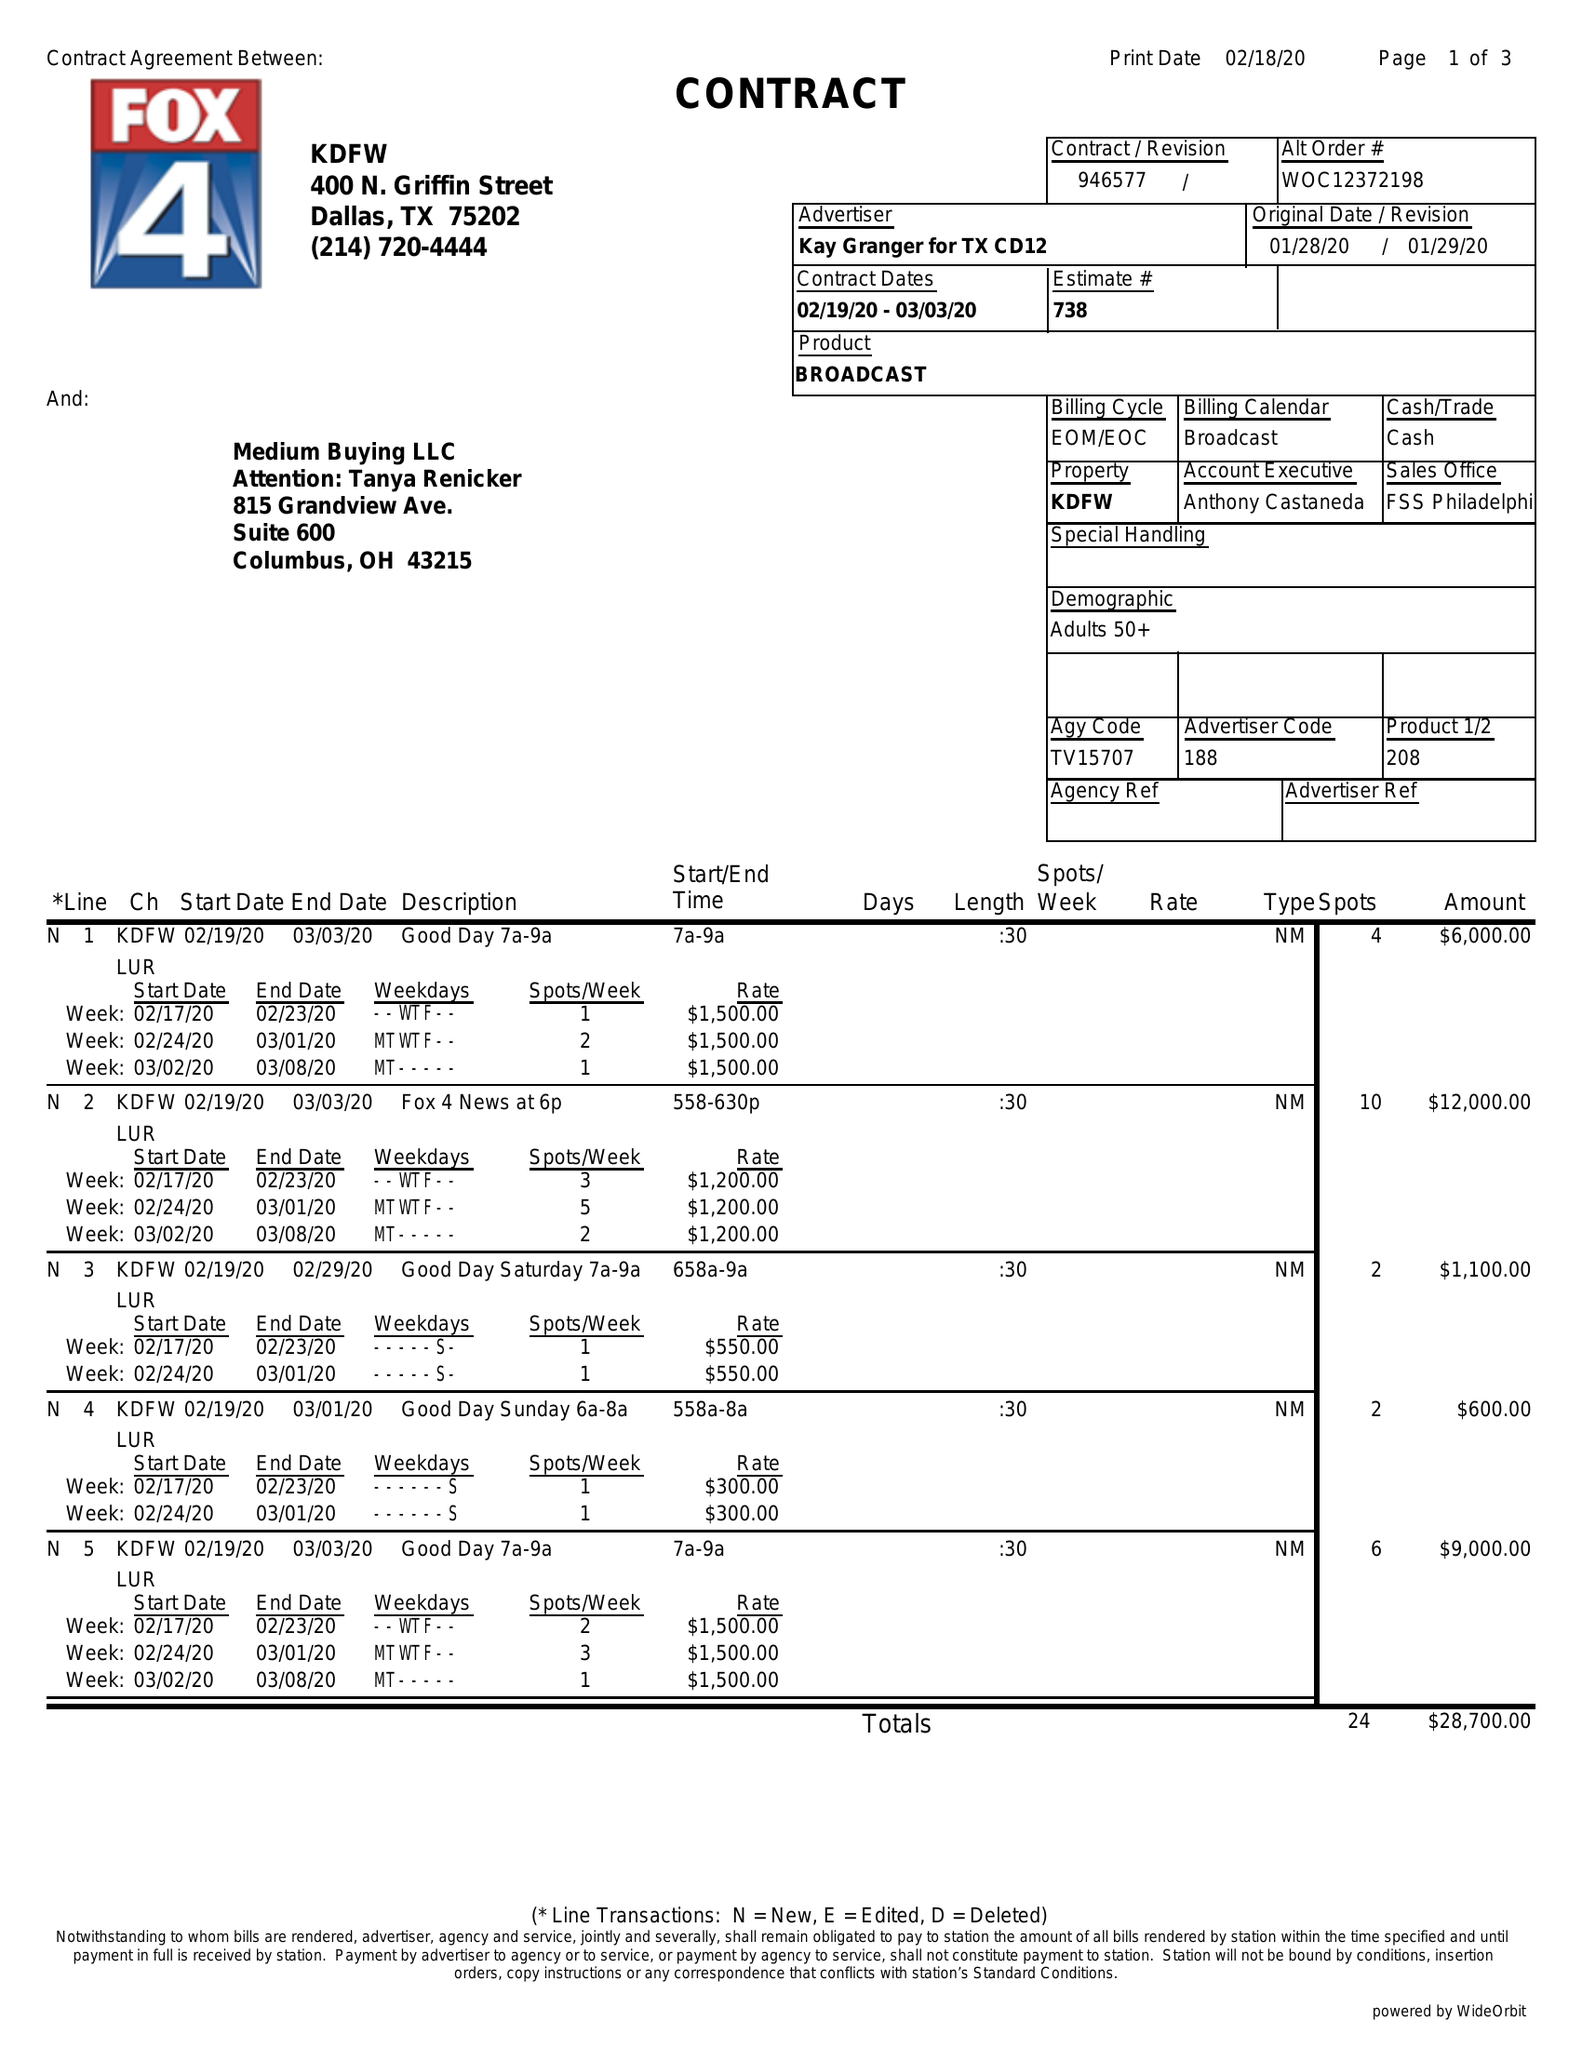What is the value for the contract_num?
Answer the question using a single word or phrase. 946577 